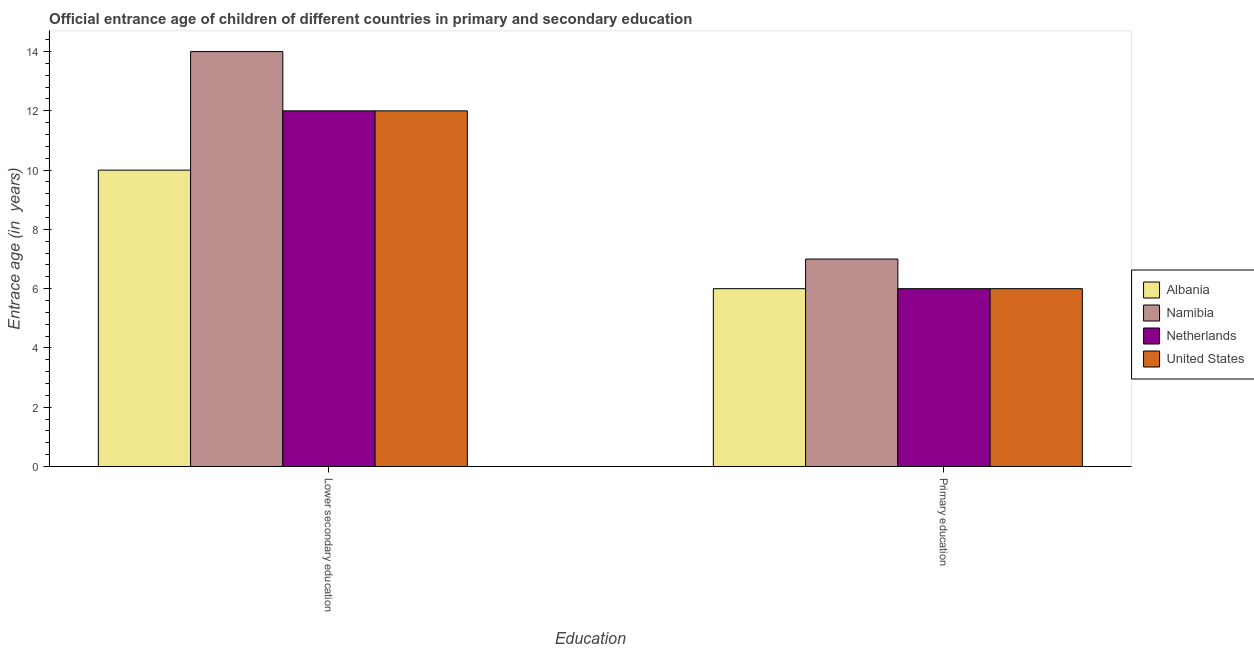How many different coloured bars are there?
Keep it short and to the point. 4. How many groups of bars are there?
Offer a very short reply. 2. Are the number of bars per tick equal to the number of legend labels?
Offer a terse response. Yes. What is the label of the 2nd group of bars from the left?
Your answer should be very brief. Primary education. Across all countries, what is the maximum entrance age of children in lower secondary education?
Offer a terse response. 14. Across all countries, what is the minimum entrance age of children in lower secondary education?
Your answer should be very brief. 10. In which country was the entrance age of children in lower secondary education maximum?
Your response must be concise. Namibia. In which country was the entrance age of chiildren in primary education minimum?
Offer a terse response. Albania. What is the total entrance age of chiildren in primary education in the graph?
Give a very brief answer. 25. What is the difference between the entrance age of chiildren in primary education in Albania and that in Netherlands?
Give a very brief answer. 0. What is the difference between the entrance age of children in lower secondary education in Netherlands and the entrance age of chiildren in primary education in Namibia?
Keep it short and to the point. 5. What is the average entrance age of chiildren in primary education per country?
Your response must be concise. 6.25. What is the difference between the entrance age of children in lower secondary education and entrance age of chiildren in primary education in Albania?
Your answer should be compact. 4. In how many countries, is the entrance age of children in lower secondary education greater than 2 years?
Provide a short and direct response. 4. What is the ratio of the entrance age of chiildren in primary education in United States to that in Netherlands?
Your answer should be compact. 1. Is the entrance age of children in lower secondary education in Namibia less than that in Netherlands?
Provide a succinct answer. No. In how many countries, is the entrance age of children in lower secondary education greater than the average entrance age of children in lower secondary education taken over all countries?
Offer a terse response. 1. What does the 4th bar from the left in Lower secondary education represents?
Keep it short and to the point. United States. What does the 2nd bar from the right in Lower secondary education represents?
Provide a succinct answer. Netherlands. How many bars are there?
Your answer should be very brief. 8. Are all the bars in the graph horizontal?
Your answer should be compact. No. What is the difference between two consecutive major ticks on the Y-axis?
Provide a succinct answer. 2. Are the values on the major ticks of Y-axis written in scientific E-notation?
Provide a succinct answer. No. Does the graph contain any zero values?
Make the answer very short. No. Does the graph contain grids?
Make the answer very short. No. How many legend labels are there?
Your answer should be very brief. 4. How are the legend labels stacked?
Keep it short and to the point. Vertical. What is the title of the graph?
Give a very brief answer. Official entrance age of children of different countries in primary and secondary education. What is the label or title of the X-axis?
Your answer should be very brief. Education. What is the label or title of the Y-axis?
Offer a very short reply. Entrace age (in  years). What is the Entrace age (in  years) of Albania in Lower secondary education?
Your answer should be compact. 10. What is the Entrace age (in  years) in Namibia in Lower secondary education?
Offer a very short reply. 14. What is the Entrace age (in  years) in Albania in Primary education?
Your answer should be very brief. 6. What is the Entrace age (in  years) in Netherlands in Primary education?
Offer a terse response. 6. What is the Entrace age (in  years) in United States in Primary education?
Offer a very short reply. 6. Across all Education, what is the maximum Entrace age (in  years) in Namibia?
Offer a very short reply. 14. Across all Education, what is the maximum Entrace age (in  years) of Netherlands?
Ensure brevity in your answer.  12. Across all Education, what is the maximum Entrace age (in  years) in United States?
Your answer should be compact. 12. Across all Education, what is the minimum Entrace age (in  years) in Albania?
Provide a succinct answer. 6. What is the total Entrace age (in  years) in Netherlands in the graph?
Ensure brevity in your answer.  18. What is the difference between the Entrace age (in  years) in Albania in Lower secondary education and that in Primary education?
Offer a very short reply. 4. What is the difference between the Entrace age (in  years) of Namibia in Lower secondary education and that in Primary education?
Your answer should be very brief. 7. What is the difference between the Entrace age (in  years) of Albania in Lower secondary education and the Entrace age (in  years) of Netherlands in Primary education?
Your response must be concise. 4. What is the difference between the Entrace age (in  years) in Netherlands in Lower secondary education and the Entrace age (in  years) in United States in Primary education?
Give a very brief answer. 6. What is the average Entrace age (in  years) of Albania per Education?
Your answer should be compact. 8. What is the average Entrace age (in  years) of Namibia per Education?
Provide a succinct answer. 10.5. What is the difference between the Entrace age (in  years) of Albania and Entrace age (in  years) of Namibia in Lower secondary education?
Your answer should be very brief. -4. What is the difference between the Entrace age (in  years) in Namibia and Entrace age (in  years) in Netherlands in Lower secondary education?
Your answer should be very brief. 2. What is the difference between the Entrace age (in  years) in Netherlands and Entrace age (in  years) in United States in Lower secondary education?
Provide a short and direct response. 0. What is the difference between the Entrace age (in  years) of Albania and Entrace age (in  years) of Netherlands in Primary education?
Your response must be concise. 0. What is the difference between the Entrace age (in  years) in Albania and Entrace age (in  years) in United States in Primary education?
Keep it short and to the point. 0. What is the difference between the Entrace age (in  years) of Namibia and Entrace age (in  years) of Netherlands in Primary education?
Provide a succinct answer. 1. What is the ratio of the Entrace age (in  years) of Albania in Lower secondary education to that in Primary education?
Your answer should be very brief. 1.67. What is the ratio of the Entrace age (in  years) in Namibia in Lower secondary education to that in Primary education?
Offer a very short reply. 2. What is the ratio of the Entrace age (in  years) of Netherlands in Lower secondary education to that in Primary education?
Give a very brief answer. 2. What is the ratio of the Entrace age (in  years) of United States in Lower secondary education to that in Primary education?
Offer a terse response. 2. What is the difference between the highest and the second highest Entrace age (in  years) of Albania?
Make the answer very short. 4. What is the difference between the highest and the second highest Entrace age (in  years) of Netherlands?
Offer a terse response. 6. What is the difference between the highest and the second highest Entrace age (in  years) in United States?
Offer a terse response. 6. What is the difference between the highest and the lowest Entrace age (in  years) of United States?
Give a very brief answer. 6. 